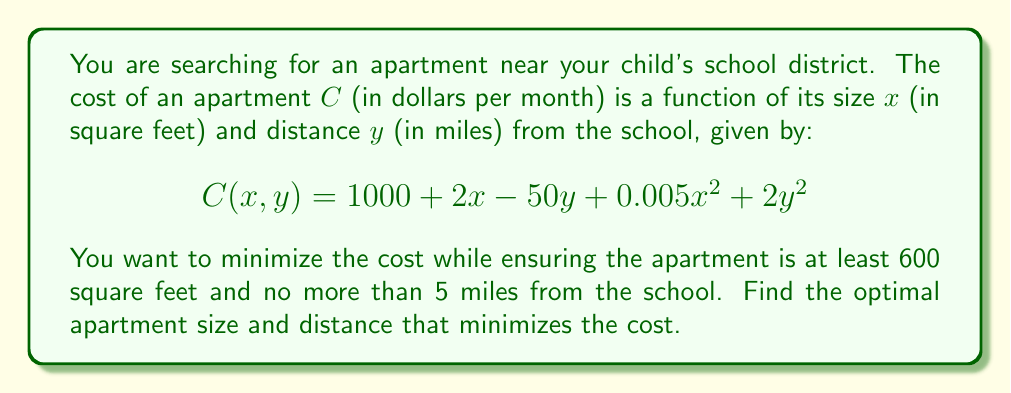Provide a solution to this math problem. To solve this optimization problem, we'll use the method of Lagrange multipliers:

1) First, let's set up the constraint equations:
   $g_1(x,y) = x - 600 \geq 0$
   $g_2(x,y) = 5 - y \geq 0$

2) The Lagrangian function is:
   $L(x,y,\lambda_1,\lambda_2) = C(x,y) - \lambda_1(x-600) - \lambda_2(5-y)$

3) We find the partial derivatives and set them to zero:
   $\frac{\partial L}{\partial x} = 2 + 0.01x - \lambda_1 = 0$
   $\frac{\partial L}{\partial y} = -50 + 4y - \lambda_2 = 0$
   $\frac{\partial L}{\partial \lambda_1} = 600 - x \leq 0$, $\lambda_1 \geq 0$, $\lambda_1(600-x) = 0$
   $\frac{\partial L}{\partial \lambda_2} = y - 5 \leq 0$, $\lambda_2 \geq 0$, $\lambda_2(y-5) = 0$

4) From these conditions, we can deduce:
   $x = 600$ (constraint is binding)
   $y = 12.5$ (unconstrained)

5) However, $y = 12.5$ violates the constraint $y \leq 5$, so we must have:
   $y = 5$ (constraint is binding)

6) Substituting back into the original cost function:
   $C(600,5) = 1000 + 2(600) - 50(5) + 0.005(600)^2 + 2(5)^2$
              $= 1000 + 1200 - 250 + 1800 + 50$
              $= 3800$

Therefore, the optimal apartment size is 600 square feet, located 5 miles from the school, with a monthly cost of $3800.
Answer: 600 sq ft, 5 miles, $3800/month 